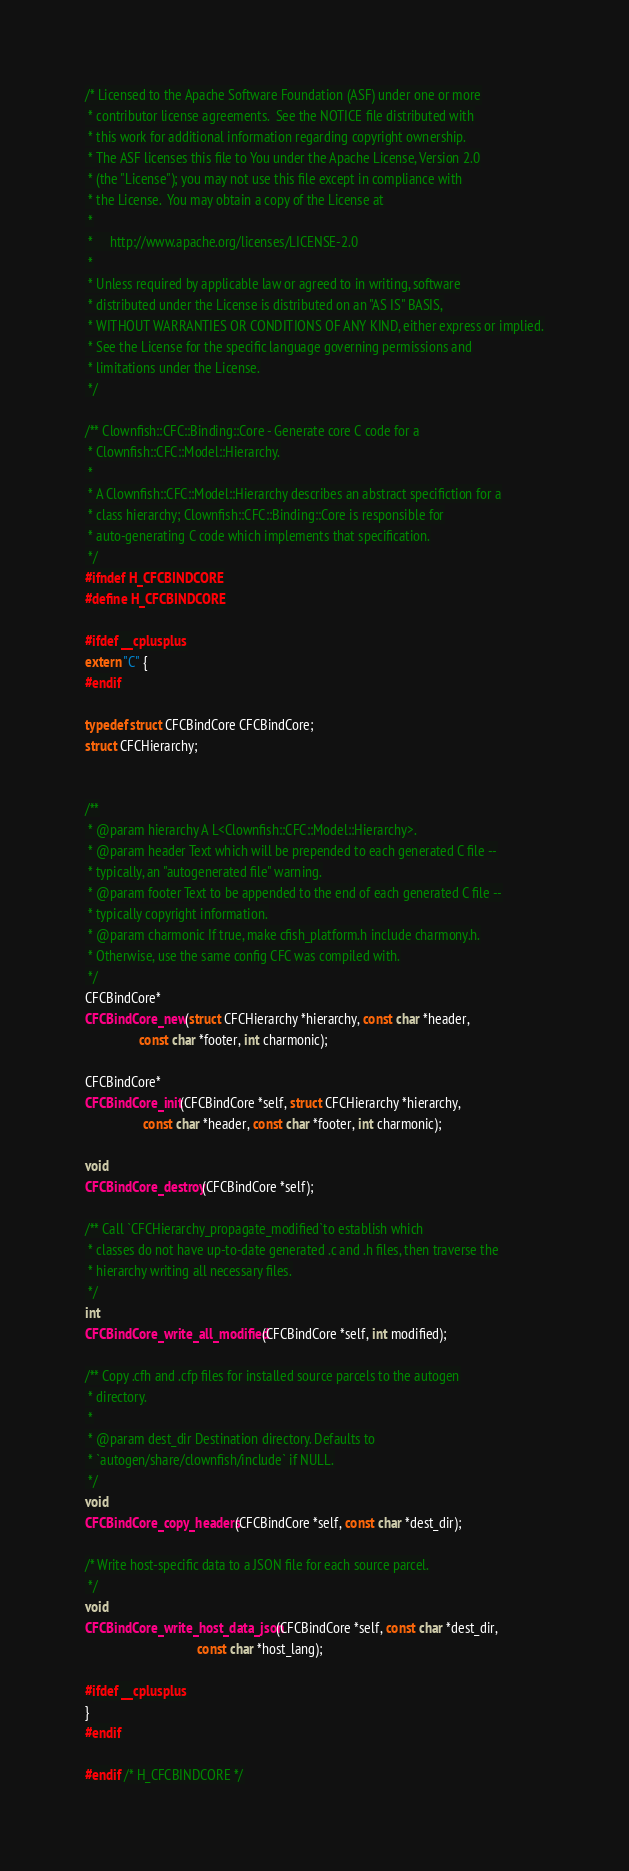<code> <loc_0><loc_0><loc_500><loc_500><_C_>/* Licensed to the Apache Software Foundation (ASF) under one or more
 * contributor license agreements.  See the NOTICE file distributed with
 * this work for additional information regarding copyright ownership.
 * The ASF licenses this file to You under the Apache License, Version 2.0
 * (the "License"); you may not use this file except in compliance with
 * the License.  You may obtain a copy of the License at
 *
 *     http://www.apache.org/licenses/LICENSE-2.0
 *
 * Unless required by applicable law or agreed to in writing, software
 * distributed under the License is distributed on an "AS IS" BASIS,
 * WITHOUT WARRANTIES OR CONDITIONS OF ANY KIND, either express or implied.
 * See the License for the specific language governing permissions and
 * limitations under the License.
 */

/** Clownfish::CFC::Binding::Core - Generate core C code for a
 * Clownfish::CFC::Model::Hierarchy.
 *
 * A Clownfish::CFC::Model::Hierarchy describes an abstract specifiction for a
 * class hierarchy; Clownfish::CFC::Binding::Core is responsible for
 * auto-generating C code which implements that specification.
 */
#ifndef H_CFCBINDCORE
#define H_CFCBINDCORE

#ifdef __cplusplus
extern "C" {
#endif

typedef struct CFCBindCore CFCBindCore;
struct CFCHierarchy;


/**
 * @param hierarchy A L<Clownfish::CFC::Model::Hierarchy>.
 * @param header Text which will be prepended to each generated C file --
 * typically, an "autogenerated file" warning.
 * @param footer Text to be appended to the end of each generated C file --
 * typically copyright information.
 * @param charmonic If true, make cfish_platform.h include charmony.h.
 * Otherwise, use the same config CFC was compiled with.
 */
CFCBindCore*
CFCBindCore_new(struct CFCHierarchy *hierarchy, const char *header,
                const char *footer, int charmonic);

CFCBindCore*
CFCBindCore_init(CFCBindCore *self, struct CFCHierarchy *hierarchy,
                 const char *header, const char *footer, int charmonic);

void
CFCBindCore_destroy(CFCBindCore *self);

/** Call `CFCHierarchy_propagate_modified`to establish which
 * classes do not have up-to-date generated .c and .h files, then traverse the
 * hierarchy writing all necessary files.
 */
int
CFCBindCore_write_all_modified(CFCBindCore *self, int modified);

/** Copy .cfh and .cfp files for installed source parcels to the autogen
 * directory.
 *
 * @param dest_dir Destination directory. Defaults to
 * `autogen/share/clownfish/include` if NULL.
 */
void
CFCBindCore_copy_headers(CFCBindCore *self, const char *dest_dir);

/* Write host-specific data to a JSON file for each source parcel.
 */
void
CFCBindCore_write_host_data_json(CFCBindCore *self, const char *dest_dir,
                                 const char *host_lang);

#ifdef __cplusplus
}
#endif

#endif /* H_CFCBINDCORE */


</code> 